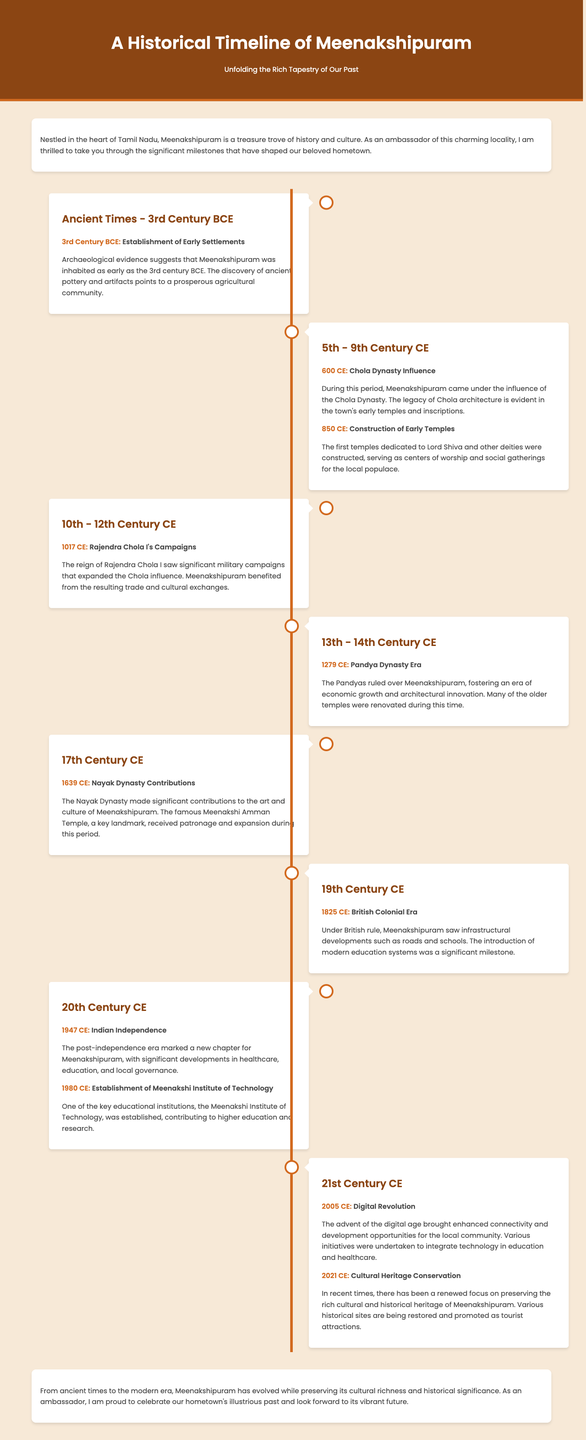What significant event occurred in Meenakshipuram in 3rd Century BCE? The document states that archaeological evidence suggests the establishment of early settlements in Meenakshipuram around 3rd Century BCE.
Answer: Establishment of Early Settlements Which dynasty influenced Meenakshipuram during the 5th to 9th Century CE? The document mentions that the Chola Dynasty had a significant influence over Meenakshipuram in this period.
Answer: Chola Dynasty What year did Rajendra Chola I conduct campaigns related to Meenakshipuram? According to the document, Rajendra Chola I's campaigns took place in 1017 CE.
Answer: 1017 CE What educational institution was established in Meenakshipuram in 1980? The document highlights that the Meenakshi Institute of Technology was established in 1980.
Answer: Meenakshi Institute of Technology What major development took place in Meenakshipuram in 2005? The document notes that the digital revolution began in 2005, enhancing connectivity and opportunities.
Answer: Digital Revolution How did the Pandyas contribute to Meenakshipuram? The document states that the Pandyas fostered an era of economic growth and architectural innovation in Meenakshipuram.
Answer: Economic growth and architectural innovation What was the focus of efforts in 2021 regarding Meenakshipuram? The document mentions the renewed focus on cultural heritage conservation in 2021.
Answer: Cultural Heritage Conservation In which century did the Nayak Dynasty make contributions to Meenakshipuram? The document indicates that the Nayak Dynasty made contributions in the 17th Century CE.
Answer: 17th Century CE 